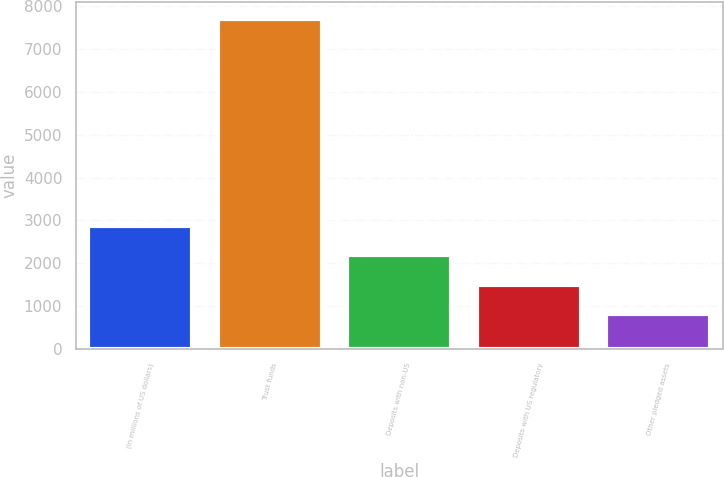Convert chart to OTSL. <chart><loc_0><loc_0><loc_500><loc_500><bar_chart><fcel>(in millions of US dollars)<fcel>Trust funds<fcel>Deposits with non-US<fcel>Deposits with US regulatory<fcel>Other pledged assets<nl><fcel>2877.1<fcel>7712<fcel>2186.4<fcel>1495.7<fcel>805<nl></chart> 